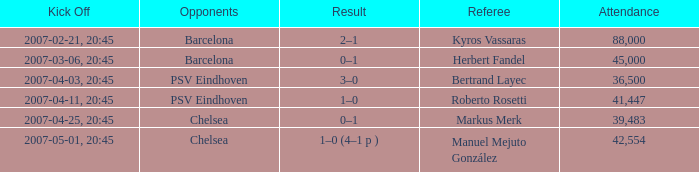How did the game that kicked off at 20:45 on the 6th of march, 2007, end in terms of score? 0–1. 